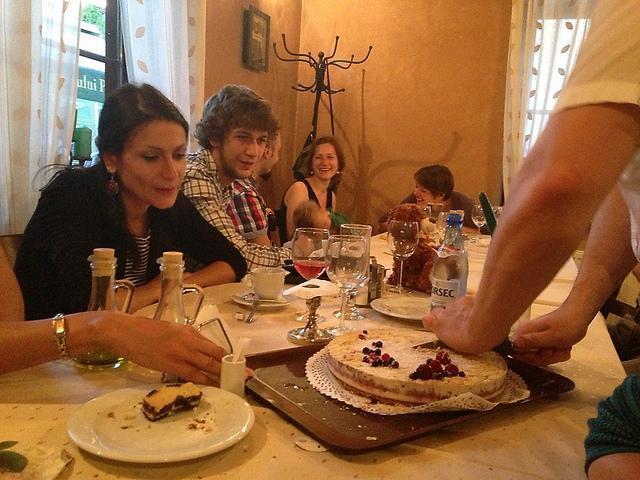What will the people shown here have for dessert?
Indicate the correct response and explain using: 'Answer: answer
Rationale: rationale.'
Options: Waffles, ice cream, pie, cheesecake. Answer: cheesecake.
Rationale: They will eat the cake the person is cutting 